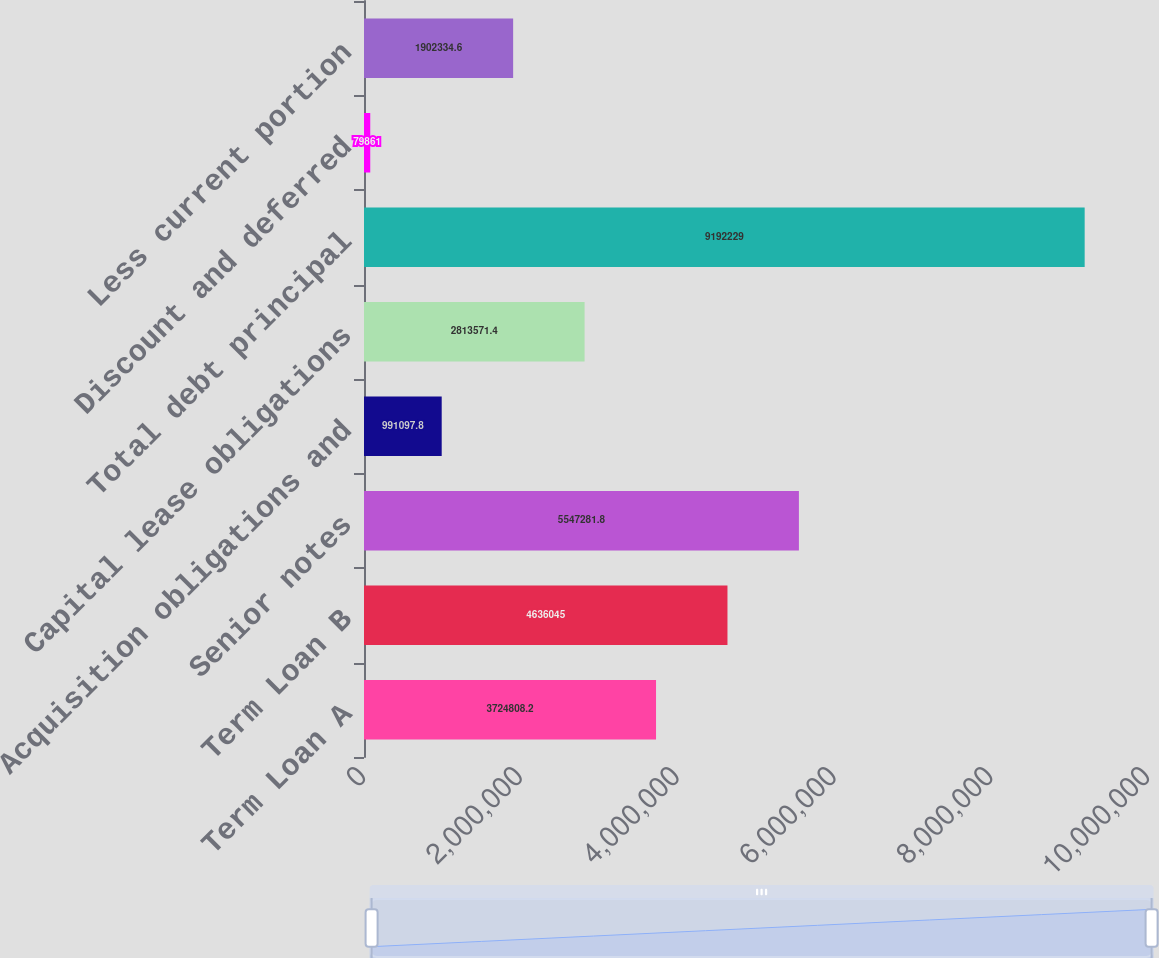Convert chart to OTSL. <chart><loc_0><loc_0><loc_500><loc_500><bar_chart><fcel>Term Loan A<fcel>Term Loan B<fcel>Senior notes<fcel>Acquisition obligations and<fcel>Capital lease obligations<fcel>Total debt principal<fcel>Discount and deferred<fcel>Less current portion<nl><fcel>3.72481e+06<fcel>4.63604e+06<fcel>5.54728e+06<fcel>991098<fcel>2.81357e+06<fcel>9.19223e+06<fcel>79861<fcel>1.90233e+06<nl></chart> 